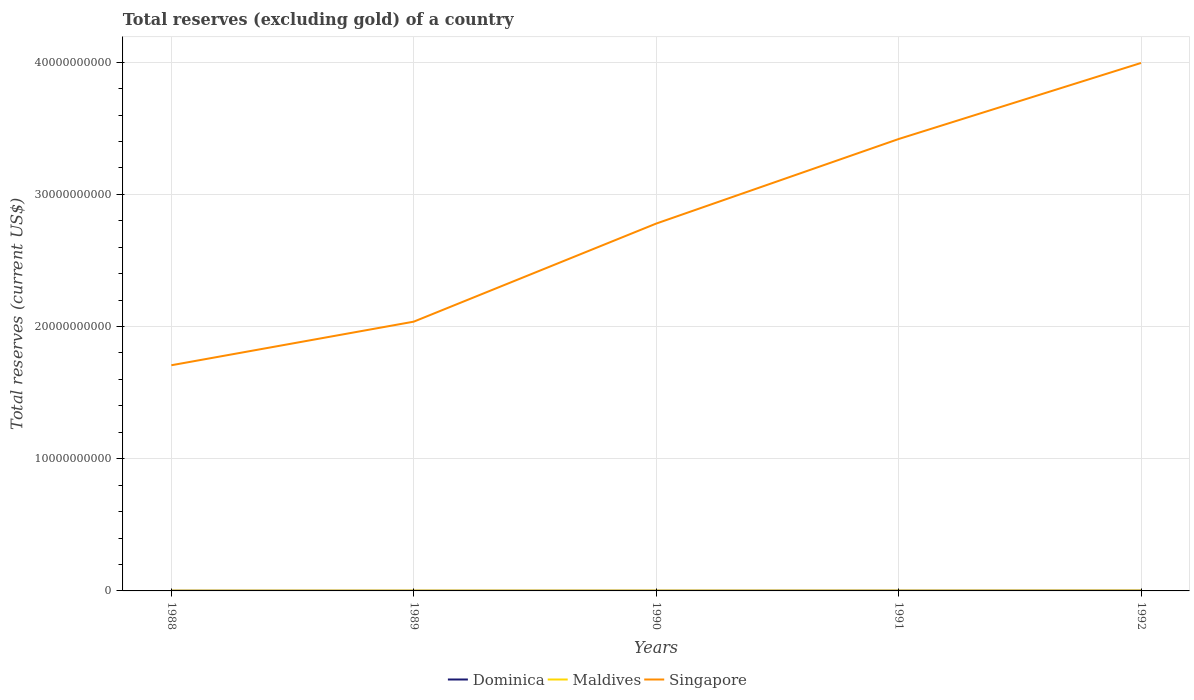How many different coloured lines are there?
Give a very brief answer. 3. Across all years, what is the maximum total reserves (excluding gold) in Singapore?
Offer a very short reply. 1.71e+1. In which year was the total reserves (excluding gold) in Maldives maximum?
Ensure brevity in your answer.  1988. What is the total total reserves (excluding gold) in Maldives in the graph?
Offer a terse response. 1.30e+06. What is the difference between the highest and the second highest total reserves (excluding gold) in Singapore?
Provide a succinct answer. 2.29e+1. How many years are there in the graph?
Give a very brief answer. 5. Are the values on the major ticks of Y-axis written in scientific E-notation?
Your answer should be very brief. No. Does the graph contain any zero values?
Provide a succinct answer. No. Where does the legend appear in the graph?
Your answer should be very brief. Bottom center. How are the legend labels stacked?
Your answer should be compact. Horizontal. What is the title of the graph?
Offer a very short reply. Total reserves (excluding gold) of a country. Does "Turkmenistan" appear as one of the legend labels in the graph?
Provide a short and direct response. No. What is the label or title of the Y-axis?
Offer a terse response. Total reserves (current US$). What is the Total reserves (current US$) in Dominica in 1988?
Keep it short and to the point. 1.41e+07. What is the Total reserves (current US$) of Maldives in 1988?
Offer a very short reply. 2.16e+07. What is the Total reserves (current US$) in Singapore in 1988?
Your response must be concise. 1.71e+1. What is the Total reserves (current US$) in Dominica in 1989?
Make the answer very short. 1.17e+07. What is the Total reserves (current US$) of Maldives in 1989?
Keep it short and to the point. 2.48e+07. What is the Total reserves (current US$) in Singapore in 1989?
Make the answer very short. 2.04e+1. What is the Total reserves (current US$) in Dominica in 1990?
Your answer should be compact. 1.45e+07. What is the Total reserves (current US$) of Maldives in 1990?
Give a very brief answer. 2.44e+07. What is the Total reserves (current US$) in Singapore in 1990?
Provide a succinct answer. 2.78e+1. What is the Total reserves (current US$) of Dominica in 1991?
Your answer should be compact. 1.78e+07. What is the Total reserves (current US$) in Maldives in 1991?
Ensure brevity in your answer.  2.35e+07. What is the Total reserves (current US$) of Singapore in 1991?
Provide a short and direct response. 3.42e+1. What is the Total reserves (current US$) in Dominica in 1992?
Your answer should be very brief. 2.04e+07. What is the Total reserves (current US$) in Maldives in 1992?
Provide a short and direct response. 2.82e+07. What is the Total reserves (current US$) of Singapore in 1992?
Keep it short and to the point. 3.99e+1. Across all years, what is the maximum Total reserves (current US$) of Dominica?
Your answer should be very brief. 2.04e+07. Across all years, what is the maximum Total reserves (current US$) of Maldives?
Provide a short and direct response. 2.82e+07. Across all years, what is the maximum Total reserves (current US$) in Singapore?
Offer a very short reply. 3.99e+1. Across all years, what is the minimum Total reserves (current US$) of Dominica?
Keep it short and to the point. 1.17e+07. Across all years, what is the minimum Total reserves (current US$) in Maldives?
Provide a short and direct response. 2.16e+07. Across all years, what is the minimum Total reserves (current US$) in Singapore?
Offer a very short reply. 1.71e+1. What is the total Total reserves (current US$) of Dominica in the graph?
Provide a short and direct response. 7.84e+07. What is the total Total reserves (current US$) in Maldives in the graph?
Offer a very short reply. 1.22e+08. What is the total Total reserves (current US$) in Singapore in the graph?
Offer a very short reply. 1.39e+11. What is the difference between the Total reserves (current US$) in Dominica in 1988 and that in 1989?
Ensure brevity in your answer.  2.38e+06. What is the difference between the Total reserves (current US$) in Maldives in 1988 and that in 1989?
Provide a succinct answer. -3.18e+06. What is the difference between the Total reserves (current US$) in Singapore in 1988 and that in 1989?
Ensure brevity in your answer.  -3.30e+09. What is the difference between the Total reserves (current US$) of Dominica in 1988 and that in 1990?
Your answer should be compact. -3.99e+05. What is the difference between the Total reserves (current US$) in Maldives in 1988 and that in 1990?
Your answer should be very brief. -2.79e+06. What is the difference between the Total reserves (current US$) of Singapore in 1988 and that in 1990?
Provide a short and direct response. -1.07e+1. What is the difference between the Total reserves (current US$) of Dominica in 1988 and that in 1991?
Offer a very short reply. -3.71e+06. What is the difference between the Total reserves (current US$) of Maldives in 1988 and that in 1991?
Give a very brief answer. -1.88e+06. What is the difference between the Total reserves (current US$) of Singapore in 1988 and that in 1991?
Give a very brief answer. -1.71e+1. What is the difference between the Total reserves (current US$) in Dominica in 1988 and that in 1992?
Offer a terse response. -6.35e+06. What is the difference between the Total reserves (current US$) of Maldives in 1988 and that in 1992?
Keep it short and to the point. -6.61e+06. What is the difference between the Total reserves (current US$) of Singapore in 1988 and that in 1992?
Offer a very short reply. -2.29e+1. What is the difference between the Total reserves (current US$) in Dominica in 1989 and that in 1990?
Keep it short and to the point. -2.78e+06. What is the difference between the Total reserves (current US$) of Maldives in 1989 and that in 1990?
Your answer should be very brief. 3.88e+05. What is the difference between the Total reserves (current US$) of Singapore in 1989 and that in 1990?
Give a very brief answer. -7.42e+09. What is the difference between the Total reserves (current US$) of Dominica in 1989 and that in 1991?
Your answer should be very brief. -6.08e+06. What is the difference between the Total reserves (current US$) in Maldives in 1989 and that in 1991?
Provide a succinct answer. 1.30e+06. What is the difference between the Total reserves (current US$) of Singapore in 1989 and that in 1991?
Offer a terse response. -1.38e+1. What is the difference between the Total reserves (current US$) in Dominica in 1989 and that in 1992?
Your answer should be compact. -8.73e+06. What is the difference between the Total reserves (current US$) of Maldives in 1989 and that in 1992?
Ensure brevity in your answer.  -3.43e+06. What is the difference between the Total reserves (current US$) in Singapore in 1989 and that in 1992?
Offer a terse response. -1.96e+1. What is the difference between the Total reserves (current US$) of Dominica in 1990 and that in 1991?
Keep it short and to the point. -3.31e+06. What is the difference between the Total reserves (current US$) in Maldives in 1990 and that in 1991?
Your answer should be very brief. 9.10e+05. What is the difference between the Total reserves (current US$) in Singapore in 1990 and that in 1991?
Make the answer very short. -6.40e+09. What is the difference between the Total reserves (current US$) of Dominica in 1990 and that in 1992?
Your answer should be very brief. -5.95e+06. What is the difference between the Total reserves (current US$) in Maldives in 1990 and that in 1992?
Your answer should be compact. -3.82e+06. What is the difference between the Total reserves (current US$) of Singapore in 1990 and that in 1992?
Offer a terse response. -1.22e+1. What is the difference between the Total reserves (current US$) of Dominica in 1991 and that in 1992?
Your answer should be very brief. -2.64e+06. What is the difference between the Total reserves (current US$) of Maldives in 1991 and that in 1992?
Provide a succinct answer. -4.73e+06. What is the difference between the Total reserves (current US$) in Singapore in 1991 and that in 1992?
Offer a very short reply. -5.75e+09. What is the difference between the Total reserves (current US$) in Dominica in 1988 and the Total reserves (current US$) in Maldives in 1989?
Your answer should be very brief. -1.07e+07. What is the difference between the Total reserves (current US$) in Dominica in 1988 and the Total reserves (current US$) in Singapore in 1989?
Offer a terse response. -2.04e+1. What is the difference between the Total reserves (current US$) of Maldives in 1988 and the Total reserves (current US$) of Singapore in 1989?
Provide a short and direct response. -2.03e+1. What is the difference between the Total reserves (current US$) in Dominica in 1988 and the Total reserves (current US$) in Maldives in 1990?
Your response must be concise. -1.03e+07. What is the difference between the Total reserves (current US$) in Dominica in 1988 and the Total reserves (current US$) in Singapore in 1990?
Your response must be concise. -2.78e+1. What is the difference between the Total reserves (current US$) of Maldives in 1988 and the Total reserves (current US$) of Singapore in 1990?
Give a very brief answer. -2.78e+1. What is the difference between the Total reserves (current US$) of Dominica in 1988 and the Total reserves (current US$) of Maldives in 1991?
Ensure brevity in your answer.  -9.41e+06. What is the difference between the Total reserves (current US$) of Dominica in 1988 and the Total reserves (current US$) of Singapore in 1991?
Make the answer very short. -3.42e+1. What is the difference between the Total reserves (current US$) of Maldives in 1988 and the Total reserves (current US$) of Singapore in 1991?
Your answer should be compact. -3.42e+1. What is the difference between the Total reserves (current US$) of Dominica in 1988 and the Total reserves (current US$) of Maldives in 1992?
Offer a terse response. -1.41e+07. What is the difference between the Total reserves (current US$) of Dominica in 1988 and the Total reserves (current US$) of Singapore in 1992?
Your response must be concise. -3.99e+1. What is the difference between the Total reserves (current US$) in Maldives in 1988 and the Total reserves (current US$) in Singapore in 1992?
Your answer should be very brief. -3.99e+1. What is the difference between the Total reserves (current US$) in Dominica in 1989 and the Total reserves (current US$) in Maldives in 1990?
Provide a succinct answer. -1.27e+07. What is the difference between the Total reserves (current US$) of Dominica in 1989 and the Total reserves (current US$) of Singapore in 1990?
Offer a terse response. -2.78e+1. What is the difference between the Total reserves (current US$) in Maldives in 1989 and the Total reserves (current US$) in Singapore in 1990?
Your response must be concise. -2.78e+1. What is the difference between the Total reserves (current US$) of Dominica in 1989 and the Total reserves (current US$) of Maldives in 1991?
Ensure brevity in your answer.  -1.18e+07. What is the difference between the Total reserves (current US$) of Dominica in 1989 and the Total reserves (current US$) of Singapore in 1991?
Keep it short and to the point. -3.42e+1. What is the difference between the Total reserves (current US$) of Maldives in 1989 and the Total reserves (current US$) of Singapore in 1991?
Ensure brevity in your answer.  -3.42e+1. What is the difference between the Total reserves (current US$) in Dominica in 1989 and the Total reserves (current US$) in Maldives in 1992?
Your answer should be compact. -1.65e+07. What is the difference between the Total reserves (current US$) in Dominica in 1989 and the Total reserves (current US$) in Singapore in 1992?
Offer a terse response. -3.99e+1. What is the difference between the Total reserves (current US$) in Maldives in 1989 and the Total reserves (current US$) in Singapore in 1992?
Keep it short and to the point. -3.99e+1. What is the difference between the Total reserves (current US$) in Dominica in 1990 and the Total reserves (current US$) in Maldives in 1991?
Provide a short and direct response. -9.01e+06. What is the difference between the Total reserves (current US$) of Dominica in 1990 and the Total reserves (current US$) of Singapore in 1991?
Your answer should be compact. -3.42e+1. What is the difference between the Total reserves (current US$) in Maldives in 1990 and the Total reserves (current US$) in Singapore in 1991?
Offer a very short reply. -3.42e+1. What is the difference between the Total reserves (current US$) in Dominica in 1990 and the Total reserves (current US$) in Maldives in 1992?
Your answer should be compact. -1.37e+07. What is the difference between the Total reserves (current US$) of Dominica in 1990 and the Total reserves (current US$) of Singapore in 1992?
Provide a succinct answer. -3.99e+1. What is the difference between the Total reserves (current US$) in Maldives in 1990 and the Total reserves (current US$) in Singapore in 1992?
Your answer should be very brief. -3.99e+1. What is the difference between the Total reserves (current US$) in Dominica in 1991 and the Total reserves (current US$) in Maldives in 1992?
Make the answer very short. -1.04e+07. What is the difference between the Total reserves (current US$) of Dominica in 1991 and the Total reserves (current US$) of Singapore in 1992?
Keep it short and to the point. -3.99e+1. What is the difference between the Total reserves (current US$) in Maldives in 1991 and the Total reserves (current US$) in Singapore in 1992?
Your response must be concise. -3.99e+1. What is the average Total reserves (current US$) of Dominica per year?
Your answer should be very brief. 1.57e+07. What is the average Total reserves (current US$) in Maldives per year?
Make the answer very short. 2.45e+07. What is the average Total reserves (current US$) in Singapore per year?
Your answer should be very brief. 2.79e+1. In the year 1988, what is the difference between the Total reserves (current US$) in Dominica and Total reserves (current US$) in Maldives?
Your answer should be compact. -7.52e+06. In the year 1988, what is the difference between the Total reserves (current US$) of Dominica and Total reserves (current US$) of Singapore?
Your answer should be compact. -1.71e+1. In the year 1988, what is the difference between the Total reserves (current US$) in Maldives and Total reserves (current US$) in Singapore?
Provide a succinct answer. -1.71e+1. In the year 1989, what is the difference between the Total reserves (current US$) in Dominica and Total reserves (current US$) in Maldives?
Ensure brevity in your answer.  -1.31e+07. In the year 1989, what is the difference between the Total reserves (current US$) in Dominica and Total reserves (current US$) in Singapore?
Give a very brief answer. -2.04e+1. In the year 1989, what is the difference between the Total reserves (current US$) of Maldives and Total reserves (current US$) of Singapore?
Offer a terse response. -2.03e+1. In the year 1990, what is the difference between the Total reserves (current US$) in Dominica and Total reserves (current US$) in Maldives?
Give a very brief answer. -9.92e+06. In the year 1990, what is the difference between the Total reserves (current US$) in Dominica and Total reserves (current US$) in Singapore?
Your answer should be compact. -2.78e+1. In the year 1990, what is the difference between the Total reserves (current US$) of Maldives and Total reserves (current US$) of Singapore?
Your answer should be compact. -2.78e+1. In the year 1991, what is the difference between the Total reserves (current US$) in Dominica and Total reserves (current US$) in Maldives?
Your answer should be very brief. -5.70e+06. In the year 1991, what is the difference between the Total reserves (current US$) of Dominica and Total reserves (current US$) of Singapore?
Offer a terse response. -3.42e+1. In the year 1991, what is the difference between the Total reserves (current US$) in Maldives and Total reserves (current US$) in Singapore?
Make the answer very short. -3.42e+1. In the year 1992, what is the difference between the Total reserves (current US$) of Dominica and Total reserves (current US$) of Maldives?
Offer a terse response. -7.78e+06. In the year 1992, what is the difference between the Total reserves (current US$) in Dominica and Total reserves (current US$) in Singapore?
Ensure brevity in your answer.  -3.99e+1. In the year 1992, what is the difference between the Total reserves (current US$) in Maldives and Total reserves (current US$) in Singapore?
Your response must be concise. -3.99e+1. What is the ratio of the Total reserves (current US$) in Dominica in 1988 to that in 1989?
Provide a short and direct response. 1.2. What is the ratio of the Total reserves (current US$) in Maldives in 1988 to that in 1989?
Offer a terse response. 0.87. What is the ratio of the Total reserves (current US$) in Singapore in 1988 to that in 1989?
Offer a terse response. 0.84. What is the ratio of the Total reserves (current US$) in Dominica in 1988 to that in 1990?
Provide a short and direct response. 0.97. What is the ratio of the Total reserves (current US$) of Maldives in 1988 to that in 1990?
Your answer should be very brief. 0.89. What is the ratio of the Total reserves (current US$) in Singapore in 1988 to that in 1990?
Your answer should be very brief. 0.61. What is the ratio of the Total reserves (current US$) of Dominica in 1988 to that in 1991?
Offer a terse response. 0.79. What is the ratio of the Total reserves (current US$) in Maldives in 1988 to that in 1991?
Your answer should be compact. 0.92. What is the ratio of the Total reserves (current US$) in Singapore in 1988 to that in 1991?
Make the answer very short. 0.5. What is the ratio of the Total reserves (current US$) of Dominica in 1988 to that in 1992?
Keep it short and to the point. 0.69. What is the ratio of the Total reserves (current US$) of Maldives in 1988 to that in 1992?
Your answer should be very brief. 0.77. What is the ratio of the Total reserves (current US$) in Singapore in 1988 to that in 1992?
Provide a short and direct response. 0.43. What is the ratio of the Total reserves (current US$) in Dominica in 1989 to that in 1990?
Offer a very short reply. 0.81. What is the ratio of the Total reserves (current US$) of Maldives in 1989 to that in 1990?
Provide a succinct answer. 1.02. What is the ratio of the Total reserves (current US$) in Singapore in 1989 to that in 1990?
Provide a short and direct response. 0.73. What is the ratio of the Total reserves (current US$) of Dominica in 1989 to that in 1991?
Your answer should be very brief. 0.66. What is the ratio of the Total reserves (current US$) in Maldives in 1989 to that in 1991?
Your response must be concise. 1.06. What is the ratio of the Total reserves (current US$) in Singapore in 1989 to that in 1991?
Your answer should be very brief. 0.6. What is the ratio of the Total reserves (current US$) in Dominica in 1989 to that in 1992?
Ensure brevity in your answer.  0.57. What is the ratio of the Total reserves (current US$) of Maldives in 1989 to that in 1992?
Provide a short and direct response. 0.88. What is the ratio of the Total reserves (current US$) of Singapore in 1989 to that in 1992?
Offer a very short reply. 0.51. What is the ratio of the Total reserves (current US$) in Dominica in 1990 to that in 1991?
Provide a succinct answer. 0.81. What is the ratio of the Total reserves (current US$) in Maldives in 1990 to that in 1991?
Provide a short and direct response. 1.04. What is the ratio of the Total reserves (current US$) in Singapore in 1990 to that in 1991?
Provide a succinct answer. 0.81. What is the ratio of the Total reserves (current US$) of Dominica in 1990 to that in 1992?
Your answer should be compact. 0.71. What is the ratio of the Total reserves (current US$) of Maldives in 1990 to that in 1992?
Keep it short and to the point. 0.86. What is the ratio of the Total reserves (current US$) in Singapore in 1990 to that in 1992?
Your answer should be very brief. 0.7. What is the ratio of the Total reserves (current US$) of Dominica in 1991 to that in 1992?
Your answer should be very brief. 0.87. What is the ratio of the Total reserves (current US$) in Maldives in 1991 to that in 1992?
Your answer should be very brief. 0.83. What is the ratio of the Total reserves (current US$) in Singapore in 1991 to that in 1992?
Your answer should be very brief. 0.86. What is the difference between the highest and the second highest Total reserves (current US$) in Dominica?
Offer a very short reply. 2.64e+06. What is the difference between the highest and the second highest Total reserves (current US$) in Maldives?
Provide a short and direct response. 3.43e+06. What is the difference between the highest and the second highest Total reserves (current US$) of Singapore?
Provide a succinct answer. 5.75e+09. What is the difference between the highest and the lowest Total reserves (current US$) in Dominica?
Give a very brief answer. 8.73e+06. What is the difference between the highest and the lowest Total reserves (current US$) of Maldives?
Provide a short and direct response. 6.61e+06. What is the difference between the highest and the lowest Total reserves (current US$) of Singapore?
Offer a terse response. 2.29e+1. 